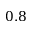<formula> <loc_0><loc_0><loc_500><loc_500>0 . 8</formula> 